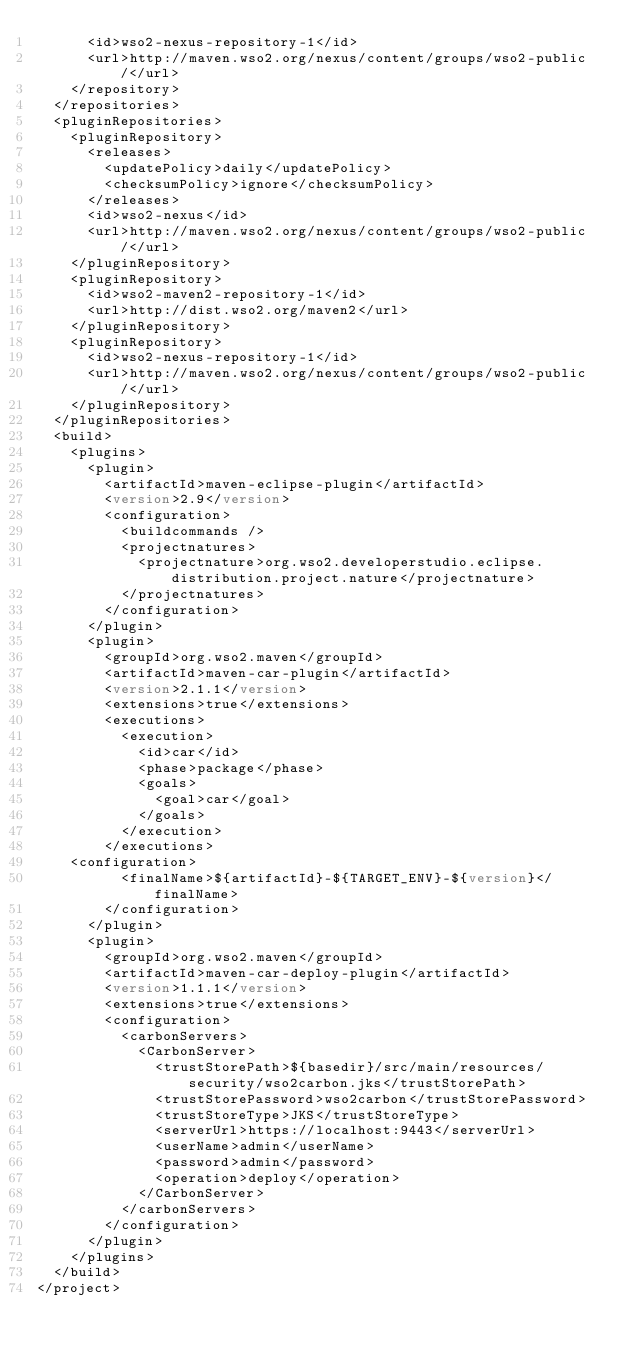<code> <loc_0><loc_0><loc_500><loc_500><_XML_>      <id>wso2-nexus-repository-1</id>
      <url>http://maven.wso2.org/nexus/content/groups/wso2-public/</url>
    </repository>
  </repositories>
  <pluginRepositories>
    <pluginRepository>
      <releases>
        <updatePolicy>daily</updatePolicy>
        <checksumPolicy>ignore</checksumPolicy>
      </releases>
      <id>wso2-nexus</id>
      <url>http://maven.wso2.org/nexus/content/groups/wso2-public/</url>
    </pluginRepository>
    <pluginRepository>
      <id>wso2-maven2-repository-1</id>
      <url>http://dist.wso2.org/maven2</url>
    </pluginRepository>
    <pluginRepository>
      <id>wso2-nexus-repository-1</id>
      <url>http://maven.wso2.org/nexus/content/groups/wso2-public/</url>
    </pluginRepository>
  </pluginRepositories>
  <build>
    <plugins>
      <plugin>
        <artifactId>maven-eclipse-plugin</artifactId>
        <version>2.9</version>
        <configuration>
          <buildcommands />
          <projectnatures>
            <projectnature>org.wso2.developerstudio.eclipse.distribution.project.nature</projectnature>
          </projectnatures>
        </configuration>
      </plugin>
      <plugin>
        <groupId>org.wso2.maven</groupId>
        <artifactId>maven-car-plugin</artifactId>
        <version>2.1.1</version>
        <extensions>true</extensions>
        <executions>
          <execution>
            <id>car</id>
            <phase>package</phase>
            <goals>
              <goal>car</goal>
            </goals>
          </execution>
        </executions>
	<configuration>
          <finalName>${artifactId}-${TARGET_ENV}-${version}</finalName>
        </configuration>
      </plugin>
      <plugin>
        <groupId>org.wso2.maven</groupId>
        <artifactId>maven-car-deploy-plugin</artifactId>
        <version>1.1.1</version>
        <extensions>true</extensions>
        <configuration>
          <carbonServers>
            <CarbonServer>
              <trustStorePath>${basedir}/src/main/resources/security/wso2carbon.jks</trustStorePath>
              <trustStorePassword>wso2carbon</trustStorePassword>
              <trustStoreType>JKS</trustStoreType>
              <serverUrl>https://localhost:9443</serverUrl>
              <userName>admin</userName>
              <password>admin</password>
              <operation>deploy</operation>
            </CarbonServer>
          </carbonServers>
        </configuration>
      </plugin>
    </plugins>
  </build>
</project>
</code> 